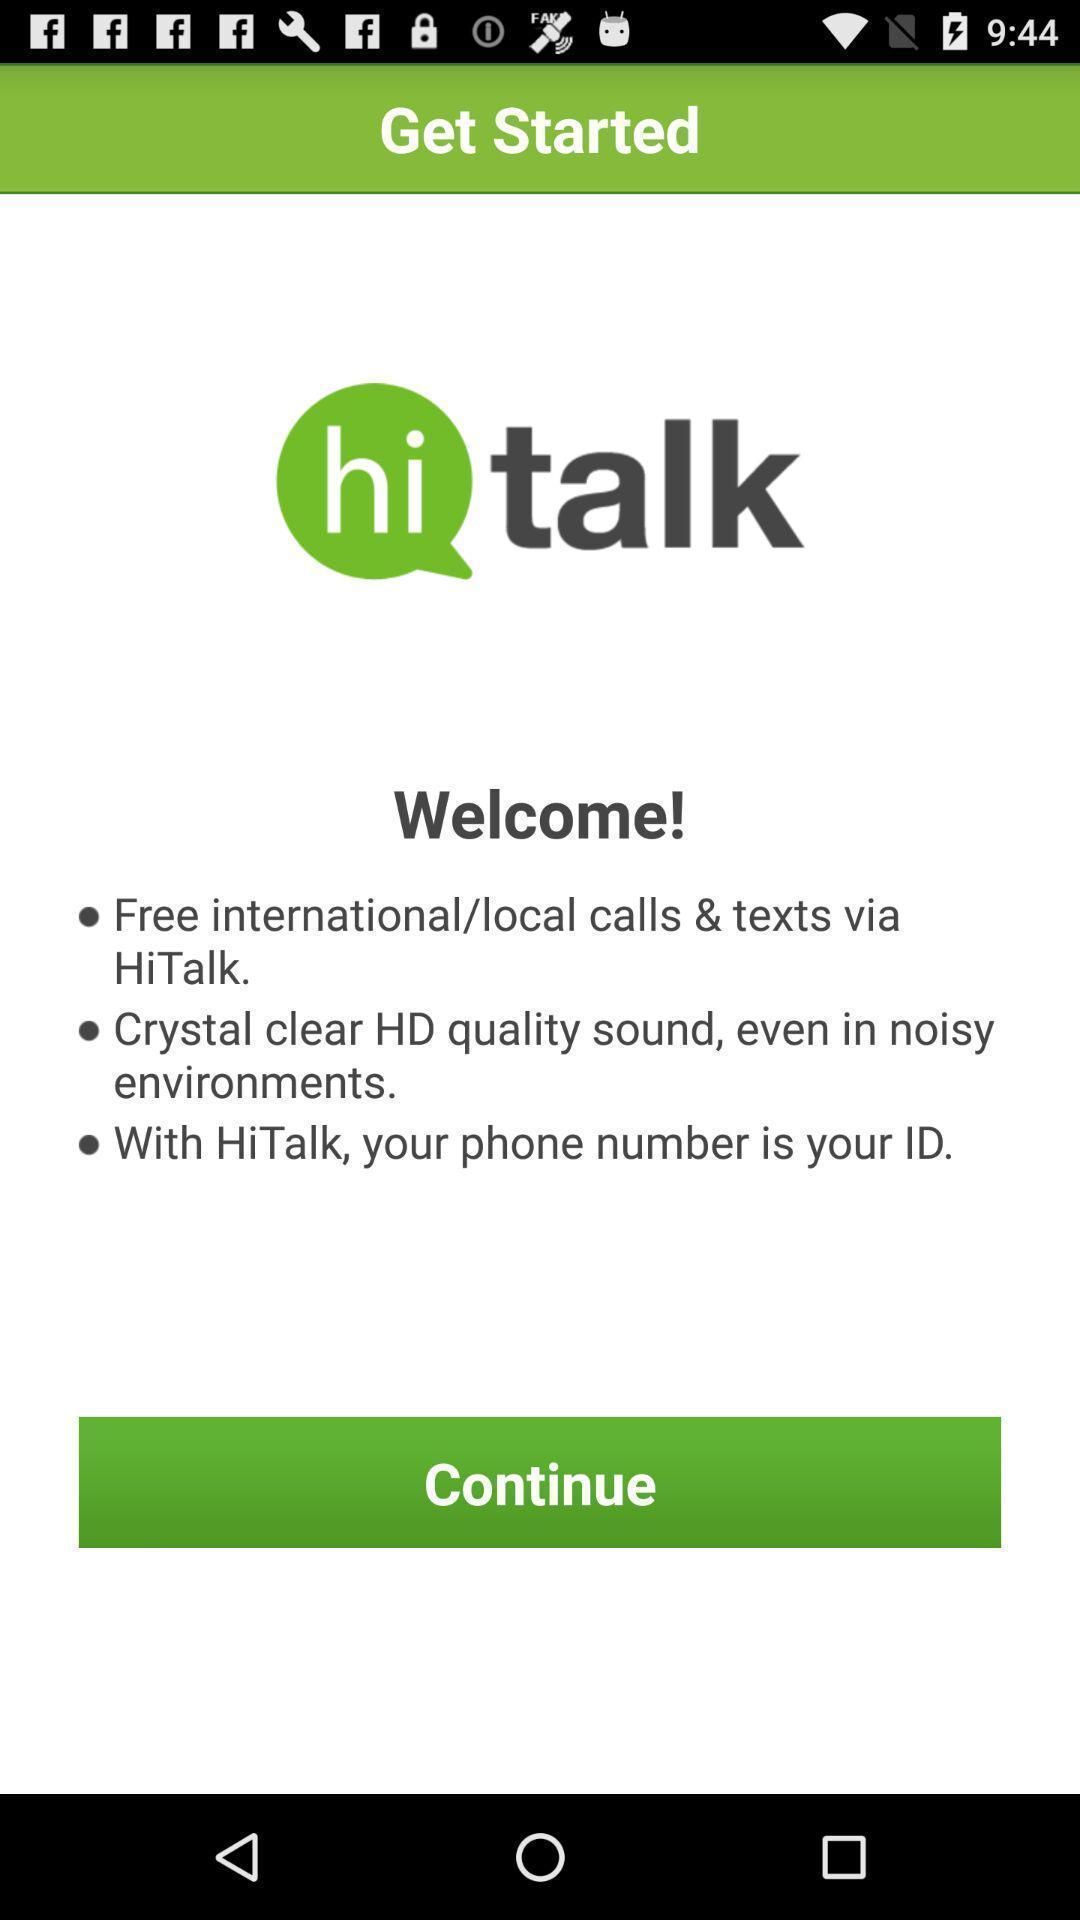Describe this image in words. Welcome page of a social media app. 